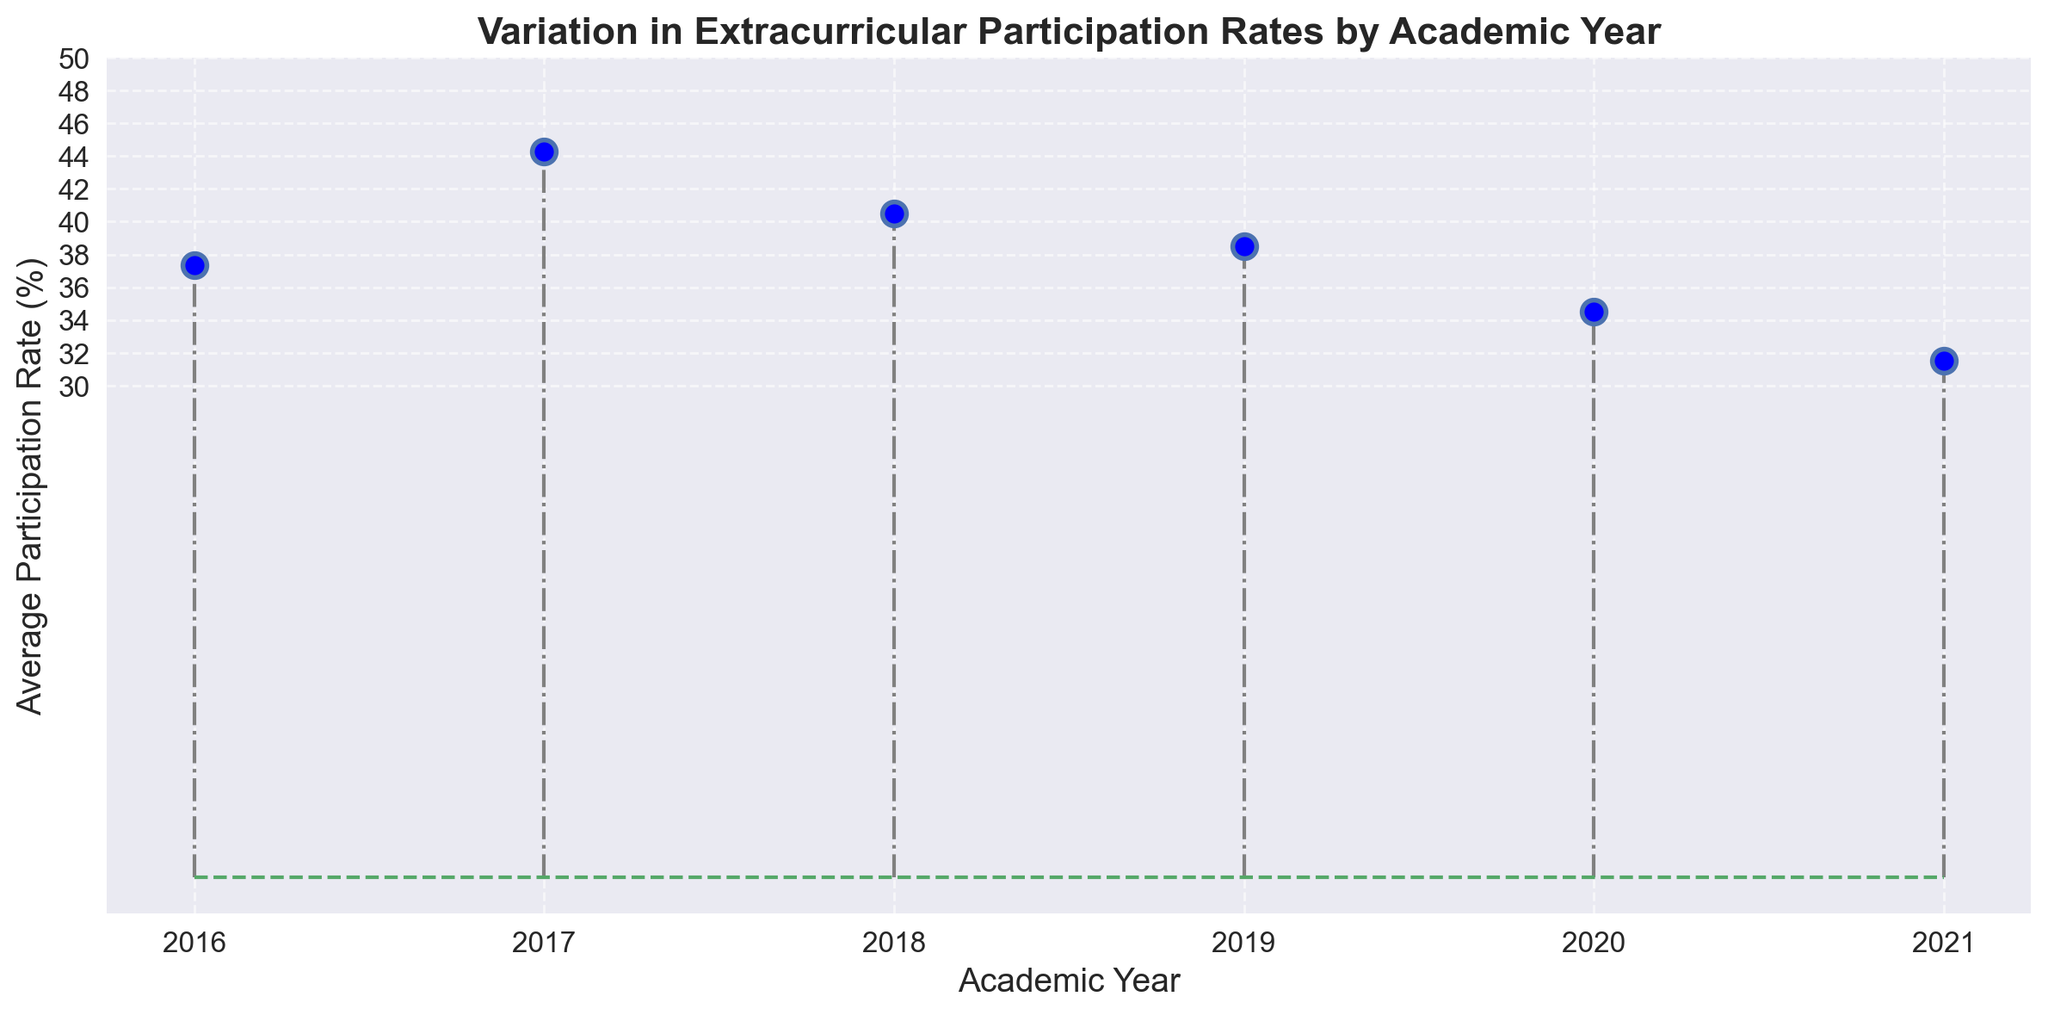What's the average participation rate in 2018? From the figure, look for the year 2018 and identify the individual participation rates: 38, 41, 43, and 40. Add them up (38+41+43+40=162) and then divide by the number of data points (4). So, 162/4 = 40.5
Answer: 40.5 Which year has the highest average participation rate? Look at the figure and identify the average participation rate for each year. Compare the averages: 2016 (37.33), 2017 (44.25), 2018 (40.5), 2019 (38.5), 2020 (34.5), 2021 (31.5). The highest is in 2017.
Answer: 2017 What is the difference in average participation rates between 2019 and 2020? Identify the average participation rates for 2019 (38.5) and 2020 (34.5). Subtract the two values (38.5 - 34.5 = 4).
Answer: 4 Is the average participation rate in 2021 greater than or less than in 2016? Compare the average participation rate in 2021 (31.5) with 2016 (37.33). Since 31.5 is less than 37.33, it is less.
Answer: Less Which year has the lowest average participation rate? Identify the average participation rate for each year and find the lowest: 2016 (37.33), 2017 (44.25), 2018 (40.5), 2019 (38.5), 2020 (34.5), 2021 (31.5). The lowest is in 2021.
Answer: 2021 What is the trend of the average participation rate from 2016 to 2021? Observe the pattern of average rates from the figure: 2016 (37.33), 2017 (44.25), 2018 (40.5), 2019 (38.5), 2020 (34.5), 2021 (31.5). The trend is a general decrease over time.
Answer: Decreasing How much did the average participation rate change from 2017 to 2018? Find the average rates for 2017 (44.25) and 2018 (40.5). Subtract the values (44.25 - 40.5 = 3.75).
Answer: 3.75 Which year experienced the largest drop in average participation rate compared to the previous year? Compare the yearly differences: 2017 to 2016 (44.25 - 37.33 = 6.92), 2018 to 2017 (40.5 - 44.25 = -3.75), 2019 to 2018 (38.5 - 40.5 = -2), 2020 to 2019 (34.5 - 38.5 = -4), 2021 to 2020 (31.5 - 34.5 = -3). The largest drop is from 2017 to 2018 (-3.75).
Answer: 2018 Is the average participation rate more variable in the years with the highest or lowest overall rates? Compare the variance (range) in years with highest (2017: 44, 42, 46, 45) and lowest (2021: 30, 32, 31, 33). The range for 2017 is 46-42=4 and for 2021 it is 33-30=3. Higher rates have more variability.
Answer: Highest What visual cue indicates the trend in participation rates over the years? Observe the height and position of the stems; they generally decrease from left (earlier years) to right (later years). This indicates a downward trend in participation rates.
Answer: Decreasing stems 